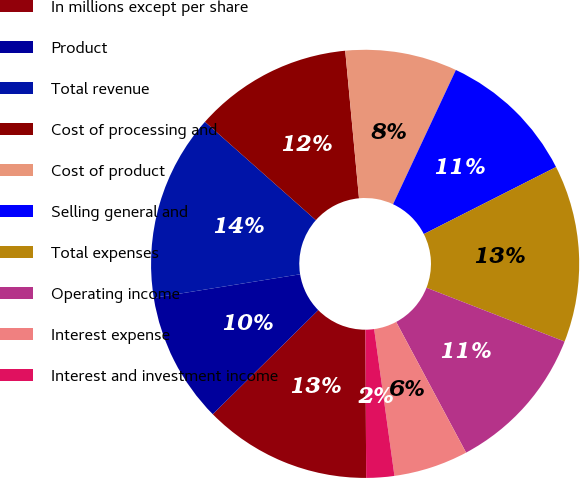<chart> <loc_0><loc_0><loc_500><loc_500><pie_chart><fcel>In millions except per share<fcel>Product<fcel>Total revenue<fcel>Cost of processing and<fcel>Cost of product<fcel>Selling general and<fcel>Total expenses<fcel>Operating income<fcel>Interest expense<fcel>Interest and investment income<nl><fcel>12.68%<fcel>9.86%<fcel>14.08%<fcel>11.97%<fcel>8.45%<fcel>10.56%<fcel>13.38%<fcel>11.27%<fcel>5.63%<fcel>2.11%<nl></chart> 